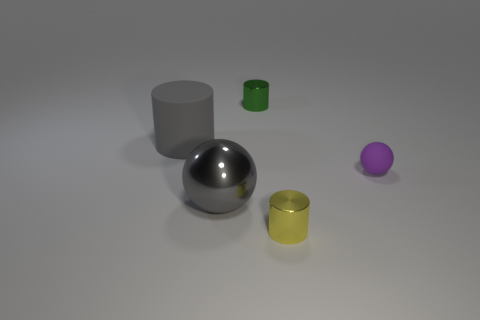What is the material of the sphere that is the same color as the large matte cylinder?
Provide a short and direct response. Metal. How many other objects are the same material as the purple ball?
Your response must be concise. 1. What is the shape of the metallic object that is behind the yellow metallic thing and in front of the tiny purple sphere?
Ensure brevity in your answer.  Sphere. There is a ball that is made of the same material as the big cylinder; what color is it?
Ensure brevity in your answer.  Purple. Are there an equal number of gray spheres that are behind the green thing and large cyan metal cylinders?
Offer a very short reply. Yes. What shape is the green metallic object that is the same size as the yellow shiny cylinder?
Your answer should be compact. Cylinder. How many other objects are the same shape as the tiny yellow metallic object?
Provide a succinct answer. 2. There is a purple rubber thing; is it the same size as the ball that is on the left side of the small purple sphere?
Offer a terse response. No. What number of objects are either balls that are to the left of the yellow thing or small yellow metallic balls?
Provide a succinct answer. 1. The gray object behind the purple rubber sphere has what shape?
Your answer should be very brief. Cylinder. 